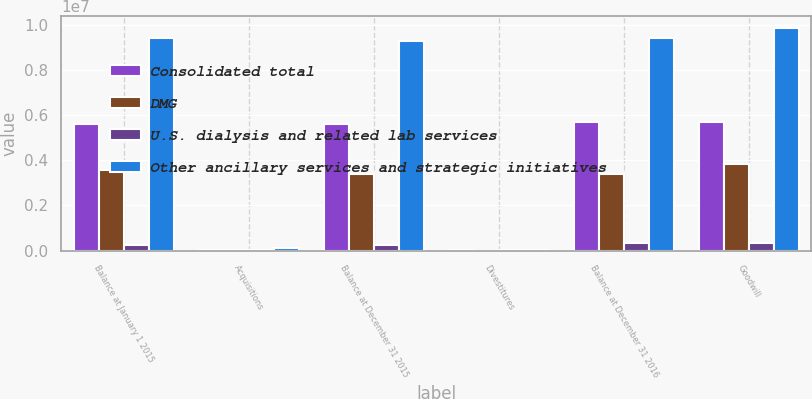Convert chart to OTSL. <chart><loc_0><loc_0><loc_500><loc_500><stacked_bar_chart><ecel><fcel>Balance at January 1 2015<fcel>Acquisitions<fcel>Balance at December 31 2015<fcel>Divestitures<fcel>Balance at December 31 2016<fcel>Goodwill<nl><fcel>Consolidated total<fcel>5.61064e+06<fcel>21910<fcel>5.62918e+06<fcel>12891<fcel>5.69159e+06<fcel>5.69159e+06<nl><fcel>DMG<fcel>3.56253e+06<fcel>29910<fcel>3.39826e+06<fcel>2223<fcel>3.39194e+06<fcel>3.83371e+06<nl><fcel>U.S. dialysis and related lab services<fcel>242118<fcel>45273<fcel>267032<fcel>29645<fcel>323788<fcel>358112<nl><fcel>Other ancillary services and strategic initiatives<fcel>9.4153e+06<fcel>97093<fcel>9.29448e+06<fcel>44759<fcel>9.40732e+06<fcel>9.88341e+06<nl></chart> 